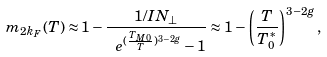Convert formula to latex. <formula><loc_0><loc_0><loc_500><loc_500>m _ { 2 k _ { F } } ( T ) \approx 1 - \frac { 1 / I N _ { \perp } } { \ e ^ { ( \frac { T _ { M 0 } } { T } ) ^ { 3 - 2 g } } - 1 } \approx 1 - \left ( \frac { T } { T ^ { * } _ { 0 } } \right ) ^ { 3 - 2 g } ,</formula> 